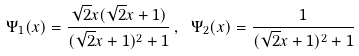Convert formula to latex. <formula><loc_0><loc_0><loc_500><loc_500>\Psi _ { 1 } ( x ) = \frac { \sqrt { 2 } x ( \sqrt { 2 } x + 1 ) } { ( \sqrt { 2 } x + 1 ) ^ { 2 } + 1 } \, , \ \Psi _ { 2 } ( x ) = \frac { 1 } { ( \sqrt { 2 } x + 1 ) ^ { 2 } + 1 }</formula> 